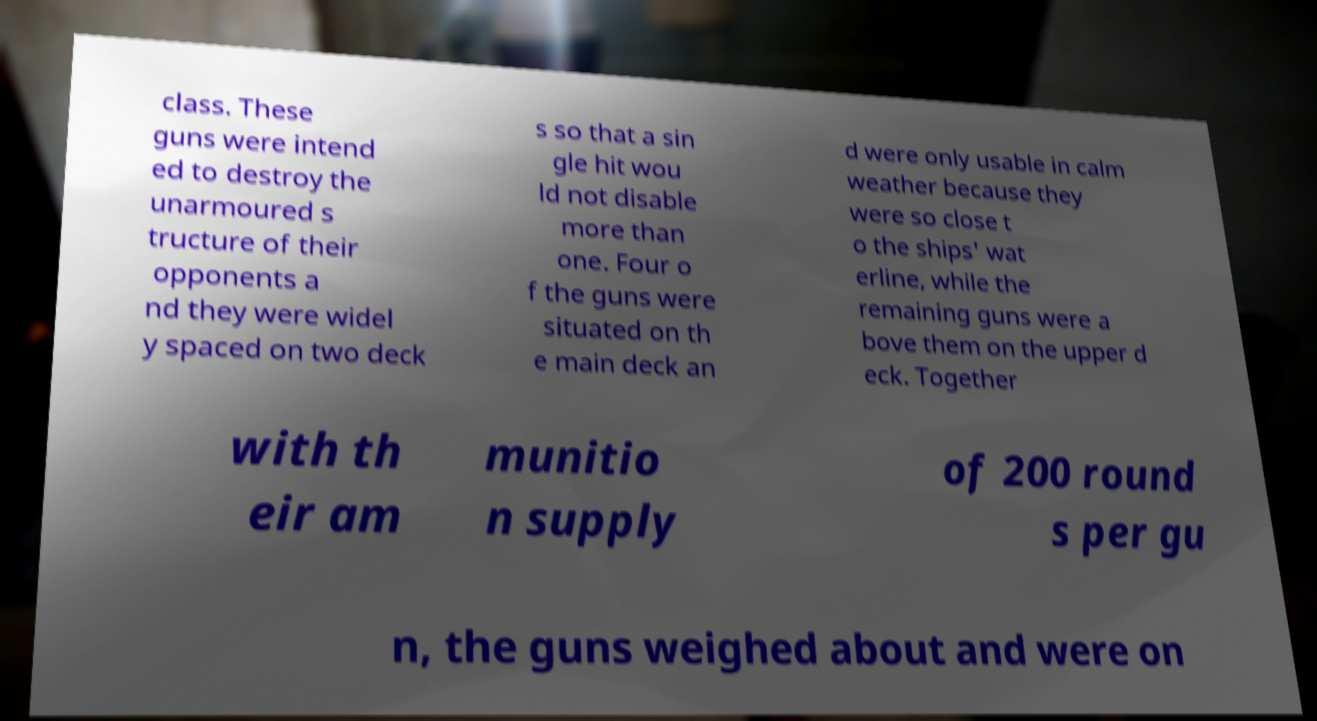There's text embedded in this image that I need extracted. Can you transcribe it verbatim? class. These guns were intend ed to destroy the unarmoured s tructure of their opponents a nd they were widel y spaced on two deck s so that a sin gle hit wou ld not disable more than one. Four o f the guns were situated on th e main deck an d were only usable in calm weather because they were so close t o the ships' wat erline, while the remaining guns were a bove them on the upper d eck. Together with th eir am munitio n supply of 200 round s per gu n, the guns weighed about and were on 